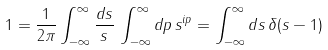<formula> <loc_0><loc_0><loc_500><loc_500>1 = \frac { 1 } { 2 \pi } \int _ { - \infty } ^ { \infty } \frac { d s } { s } \, \int _ { - \infty } ^ { \infty } d p \, s ^ { i p } = \int _ { - \infty } ^ { \infty } d s \, \delta ( s - 1 )</formula> 